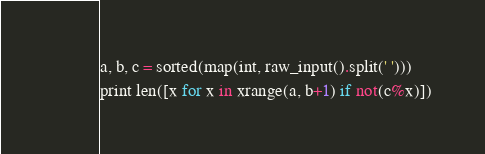Convert code to text. <code><loc_0><loc_0><loc_500><loc_500><_Python_>a, b, c = sorted(map(int, raw_input().split(' ')))
print len([x for x in xrange(a, b+1) if not(c%x)])</code> 